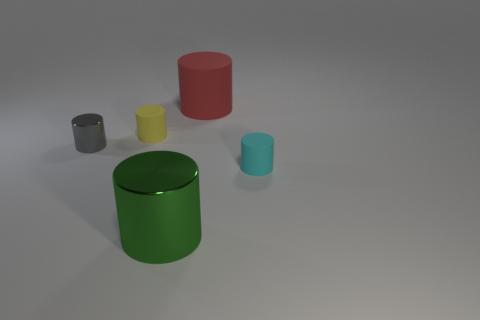Are there the same number of tiny objects in front of the gray metallic object and small yellow cylinders?
Ensure brevity in your answer.  Yes. Is there a small cylinder that is behind the big cylinder in front of the small cyan cylinder?
Make the answer very short. Yes. Is there any other thing that is the same color as the large metallic cylinder?
Make the answer very short. No. Is the material of the large thing behind the gray shiny thing the same as the gray cylinder?
Your response must be concise. No. Is the number of cyan things that are behind the small yellow cylinder the same as the number of large green metal cylinders on the left side of the big green object?
Offer a very short reply. Yes. How big is the metal object that is in front of the matte cylinder in front of the small metallic object?
Make the answer very short. Large. What material is the thing that is in front of the small gray metallic thing and behind the large green object?
Make the answer very short. Rubber. What number of other objects are there of the same size as the gray thing?
Give a very brief answer. 2. The big matte object has what color?
Your answer should be very brief. Red. The cyan rubber thing is what size?
Provide a succinct answer. Small. 